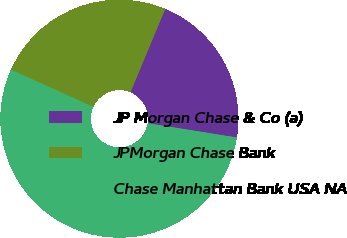Convert chart. <chart><loc_0><loc_0><loc_500><loc_500><pie_chart><fcel>JP Morgan Chase & Co (a)<fcel>JPMorgan Chase Bank<fcel>Chase Manhattan Bank USA NA<nl><fcel>21.24%<fcel>24.54%<fcel>54.23%<nl></chart> 